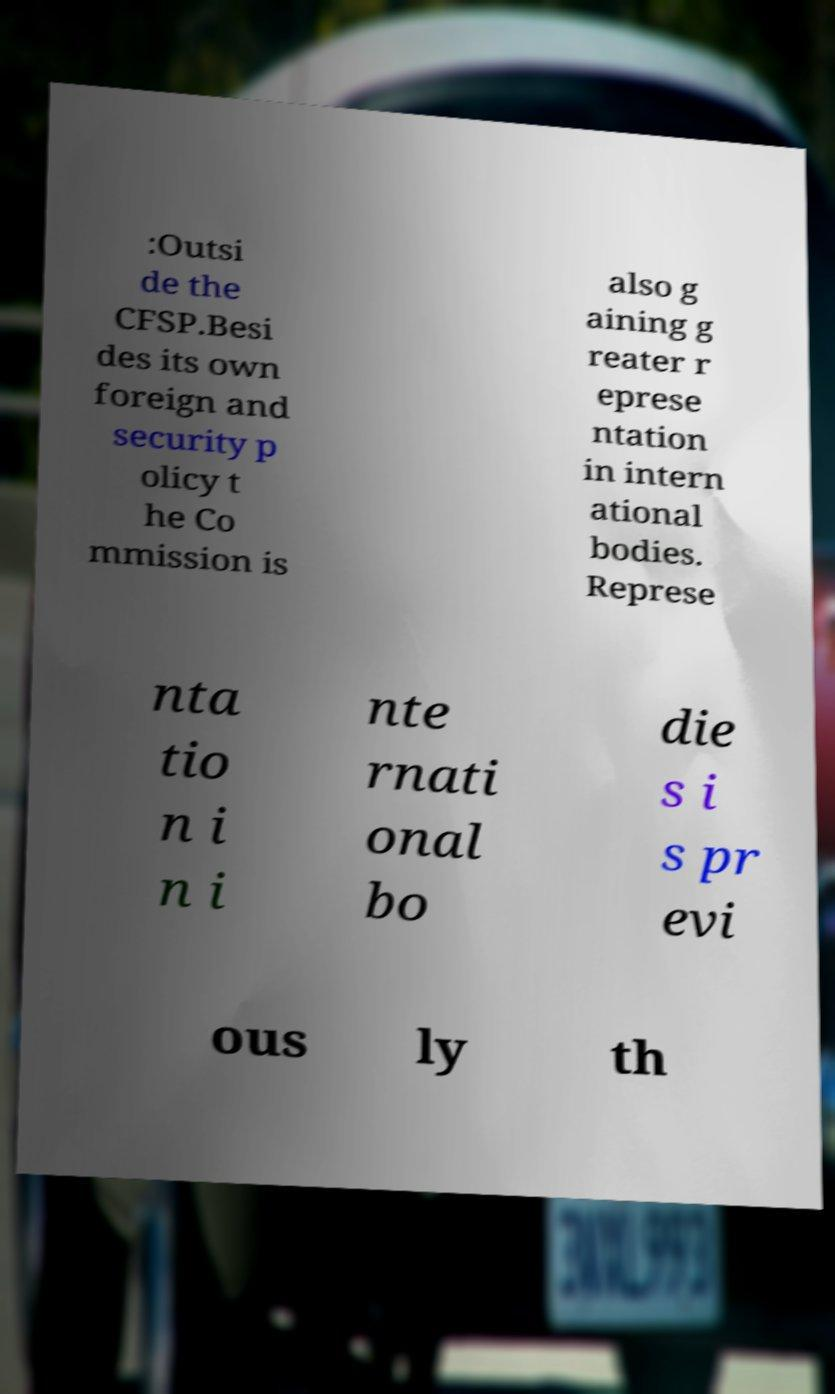What messages or text are displayed in this image? I need them in a readable, typed format. :Outsi de the CFSP.Besi des its own foreign and security p olicy t he Co mmission is also g aining g reater r eprese ntation in intern ational bodies. Represe nta tio n i n i nte rnati onal bo die s i s pr evi ous ly th 